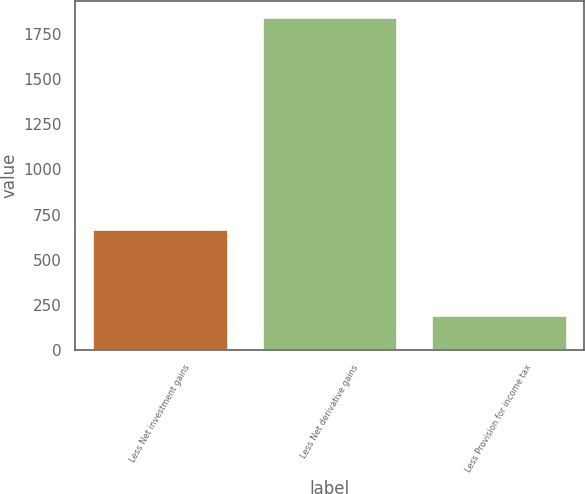Convert chart. <chart><loc_0><loc_0><loc_500><loc_500><bar_chart><fcel>Less Net investment gains<fcel>Less Net derivative gains<fcel>Less Provision for income tax<nl><fcel>669<fcel>1842<fcel>192<nl></chart> 